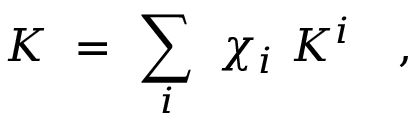Convert formula to latex. <formula><loc_0><loc_0><loc_500><loc_500>K \ = \ \sum _ { i } \ \chi _ { i } \ K ^ { i } \quad ,</formula> 